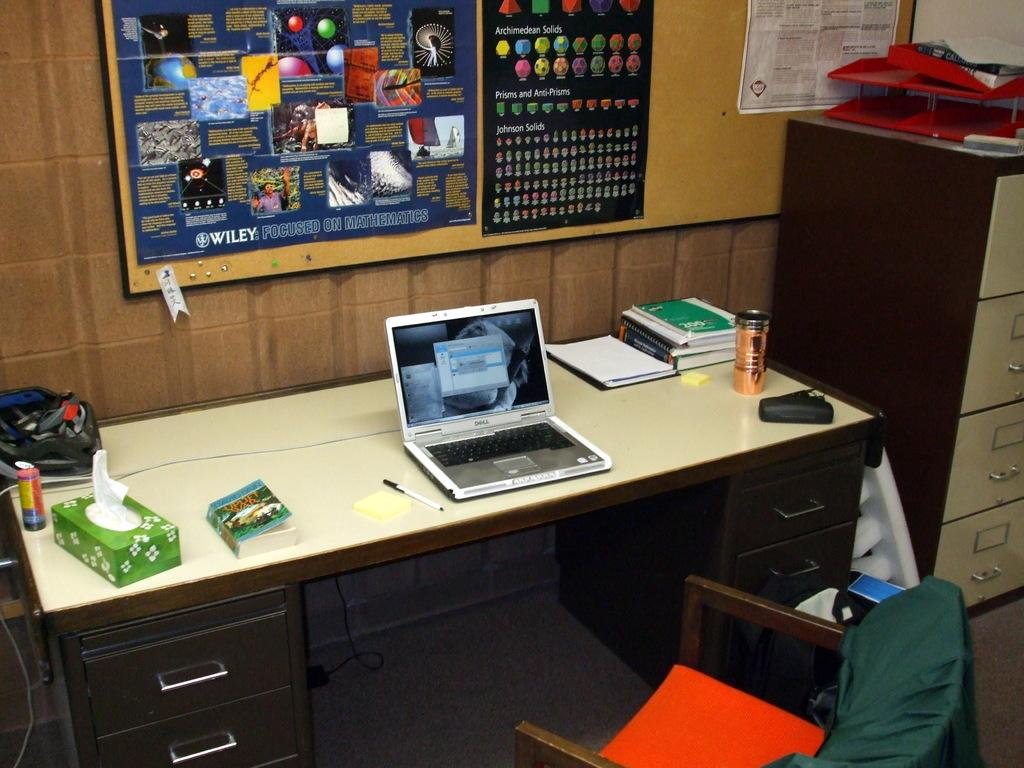<image>
Describe the image concisely. A paperback book with the word "war" in the title sits on a desk next to a box of tissues. 